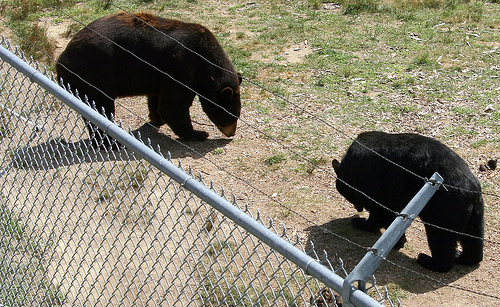Can you tell what kind of bears these are? While I cannot perform species identification with absolute certainty, the bears in the image resemble American black bears based on their size, shape, and the quality of their black fur. 